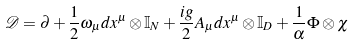<formula> <loc_0><loc_0><loc_500><loc_500>\mathcal { D } = \partial + \frac { 1 } { 2 } \omega _ { \mu } d x ^ { \mu } \otimes \mathbb { I } _ { N } + \frac { i g } { 2 } A _ { \mu } d x ^ { \mu } \otimes \mathbb { I } _ { D } + \frac { 1 } { \alpha } \Phi \otimes \chi</formula> 